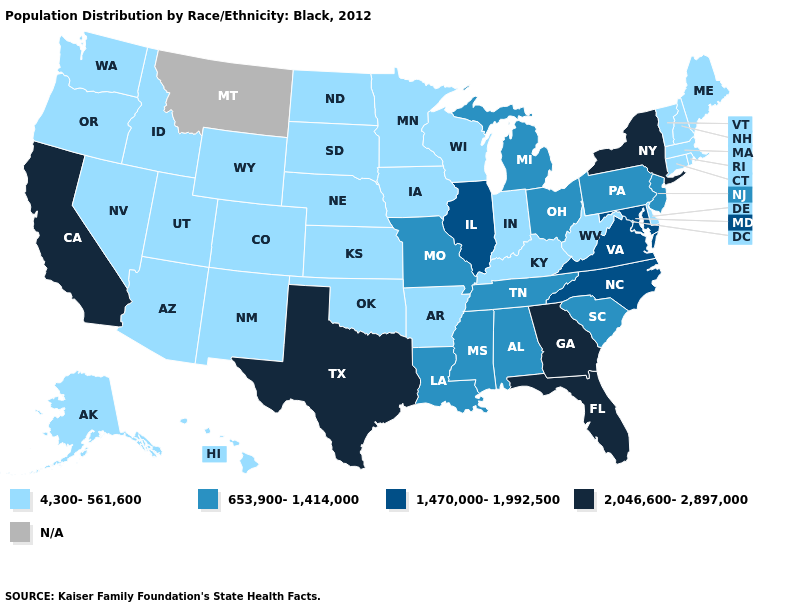Name the states that have a value in the range 653,900-1,414,000?
Keep it brief. Alabama, Louisiana, Michigan, Mississippi, Missouri, New Jersey, Ohio, Pennsylvania, South Carolina, Tennessee. Which states have the lowest value in the USA?
Quick response, please. Alaska, Arizona, Arkansas, Colorado, Connecticut, Delaware, Hawaii, Idaho, Indiana, Iowa, Kansas, Kentucky, Maine, Massachusetts, Minnesota, Nebraska, Nevada, New Hampshire, New Mexico, North Dakota, Oklahoma, Oregon, Rhode Island, South Dakota, Utah, Vermont, Washington, West Virginia, Wisconsin, Wyoming. Does the map have missing data?
Quick response, please. Yes. Name the states that have a value in the range 4,300-561,600?
Quick response, please. Alaska, Arizona, Arkansas, Colorado, Connecticut, Delaware, Hawaii, Idaho, Indiana, Iowa, Kansas, Kentucky, Maine, Massachusetts, Minnesota, Nebraska, Nevada, New Hampshire, New Mexico, North Dakota, Oklahoma, Oregon, Rhode Island, South Dakota, Utah, Vermont, Washington, West Virginia, Wisconsin, Wyoming. Name the states that have a value in the range 1,470,000-1,992,500?
Concise answer only. Illinois, Maryland, North Carolina, Virginia. Which states have the lowest value in the MidWest?
Concise answer only. Indiana, Iowa, Kansas, Minnesota, Nebraska, North Dakota, South Dakota, Wisconsin. Does the map have missing data?
Answer briefly. Yes. Which states have the lowest value in the USA?
Give a very brief answer. Alaska, Arizona, Arkansas, Colorado, Connecticut, Delaware, Hawaii, Idaho, Indiana, Iowa, Kansas, Kentucky, Maine, Massachusetts, Minnesota, Nebraska, Nevada, New Hampshire, New Mexico, North Dakota, Oklahoma, Oregon, Rhode Island, South Dakota, Utah, Vermont, Washington, West Virginia, Wisconsin, Wyoming. What is the value of Idaho?
Be succinct. 4,300-561,600. Name the states that have a value in the range 653,900-1,414,000?
Be succinct. Alabama, Louisiana, Michigan, Mississippi, Missouri, New Jersey, Ohio, Pennsylvania, South Carolina, Tennessee. Name the states that have a value in the range N/A?
Quick response, please. Montana. What is the value of Maryland?
Answer briefly. 1,470,000-1,992,500. How many symbols are there in the legend?
Keep it brief. 5. Among the states that border Tennessee , which have the highest value?
Be succinct. Georgia. What is the value of Wisconsin?
Write a very short answer. 4,300-561,600. 